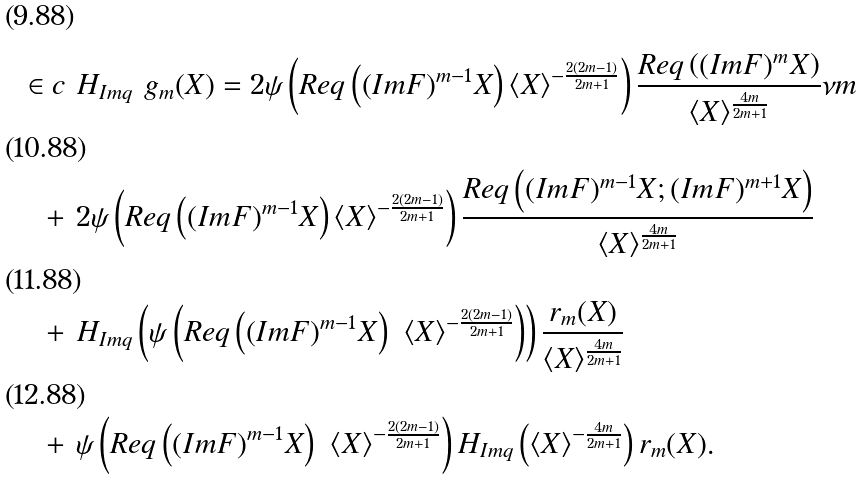<formula> <loc_0><loc_0><loc_500><loc_500>\in c & \ H _ { I m q } \ g _ { m } ( X ) = 2 \psi \left ( R e q \left ( ( I m F ) ^ { m - 1 } X \right ) \langle X \rangle ^ { - \frac { 2 ( 2 m - 1 ) } { 2 m + 1 } } \right ) \frac { R e q \left ( ( I m F ) ^ { m } X \right ) } { \langle X \rangle ^ { \frac { 4 m } { 2 m + 1 } } } \nu m \\ + & \ 2 \psi \left ( R e q \left ( ( I m F ) ^ { m - 1 } X \right ) \langle X \rangle ^ { - \frac { 2 ( 2 m - 1 ) } { 2 m + 1 } } \right ) \frac { R e q \left ( ( I m F ) ^ { m - 1 } X ; ( I m F ) ^ { m + 1 } X \right ) } { \langle X \rangle ^ { \frac { 4 m } { 2 m + 1 } } } \\ + & \ H _ { I m q } \left ( \psi \left ( R e q \left ( ( I m F ) ^ { m - 1 } X \right ) \ \langle X \rangle ^ { - \frac { 2 ( 2 m - 1 ) } { 2 m + 1 } } \right ) \right ) \frac { r _ { m } ( X ) } { \langle X \rangle ^ { \frac { 4 m } { 2 m + 1 } } } \\ + & \ \psi \left ( R e q \left ( ( I m F ) ^ { m - 1 } X \right ) \ \langle X \rangle ^ { - \frac { 2 ( 2 m - 1 ) } { 2 m + 1 } } \right ) H _ { I m q } \left ( \langle X \rangle ^ { - \frac { 4 m } { 2 m + 1 } } \right ) r _ { m } ( X ) .</formula> 